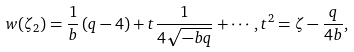Convert formula to latex. <formula><loc_0><loc_0><loc_500><loc_500>w ( \zeta _ { 2 } ) = \frac { 1 } { b } \left ( q - 4 \right ) + t \frac { 1 } { 4 \sqrt { - b q } } + \cdots , t ^ { 2 } = \zeta - \frac { q } { 4 b } ,</formula> 